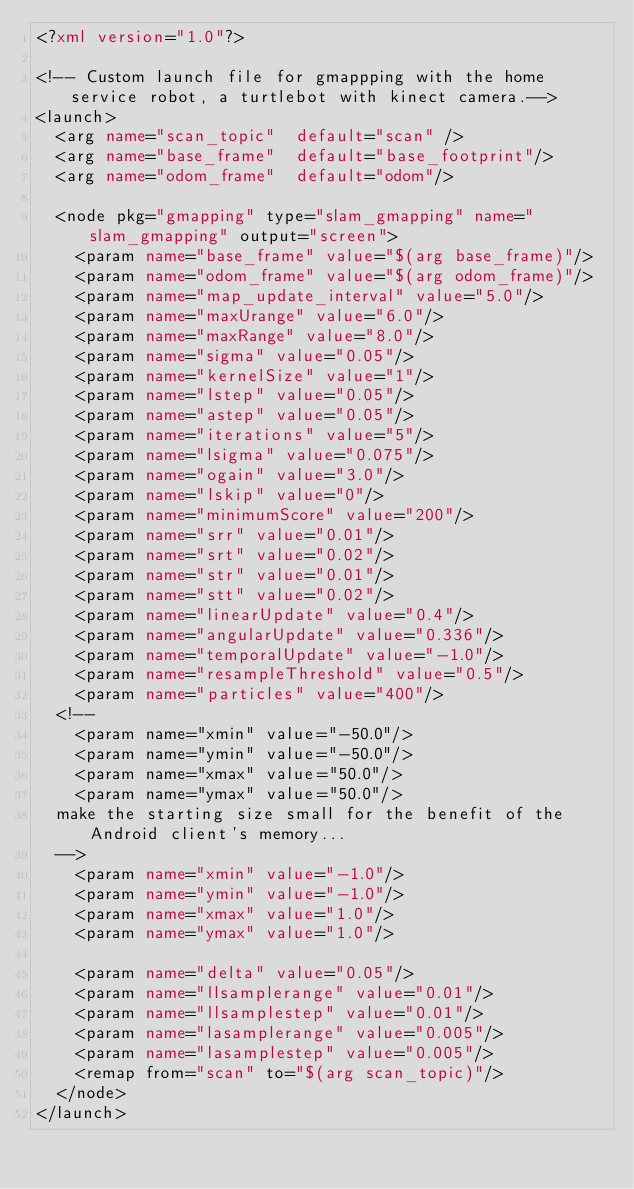Convert code to text. <code><loc_0><loc_0><loc_500><loc_500><_XML_><?xml version="1.0"?>

<!-- Custom launch file for gmappping with the home service robot, a turtlebot with kinect camera.--> 
<launch>
  <arg name="scan_topic"  default="scan" />
  <arg name="base_frame"  default="base_footprint"/>
  <arg name="odom_frame"  default="odom"/>

  <node pkg="gmapping" type="slam_gmapping" name="slam_gmapping" output="screen">
    <param name="base_frame" value="$(arg base_frame)"/>
    <param name="odom_frame" value="$(arg odom_frame)"/>
    <param name="map_update_interval" value="5.0"/>
    <param name="maxUrange" value="6.0"/>
    <param name="maxRange" value="8.0"/>
    <param name="sigma" value="0.05"/>
    <param name="kernelSize" value="1"/>
    <param name="lstep" value="0.05"/>
    <param name="astep" value="0.05"/>
    <param name="iterations" value="5"/>
    <param name="lsigma" value="0.075"/>
    <param name="ogain" value="3.0"/>
    <param name="lskip" value="0"/>
    <param name="minimumScore" value="200"/>
    <param name="srr" value="0.01"/>
    <param name="srt" value="0.02"/>
    <param name="str" value="0.01"/>
    <param name="stt" value="0.02"/>
    <param name="linearUpdate" value="0.4"/>
    <param name="angularUpdate" value="0.336"/>
    <param name="temporalUpdate" value="-1.0"/>
    <param name="resampleThreshold" value="0.5"/>
    <param name="particles" value="400"/>
  <!--
    <param name="xmin" value="-50.0"/>
    <param name="ymin" value="-50.0"/>
    <param name="xmax" value="50.0"/>
    <param name="ymax" value="50.0"/>
  make the starting size small for the benefit of the Android client's memory...
  -->
    <param name="xmin" value="-1.0"/>
    <param name="ymin" value="-1.0"/>
    <param name="xmax" value="1.0"/>
    <param name="ymax" value="1.0"/>

    <param name="delta" value="0.05"/>
    <param name="llsamplerange" value="0.01"/>
    <param name="llsamplestep" value="0.01"/>
    <param name="lasamplerange" value="0.005"/>
    <param name="lasamplestep" value="0.005"/>
    <remap from="scan" to="$(arg scan_topic)"/>
  </node>
</launch>
</code> 